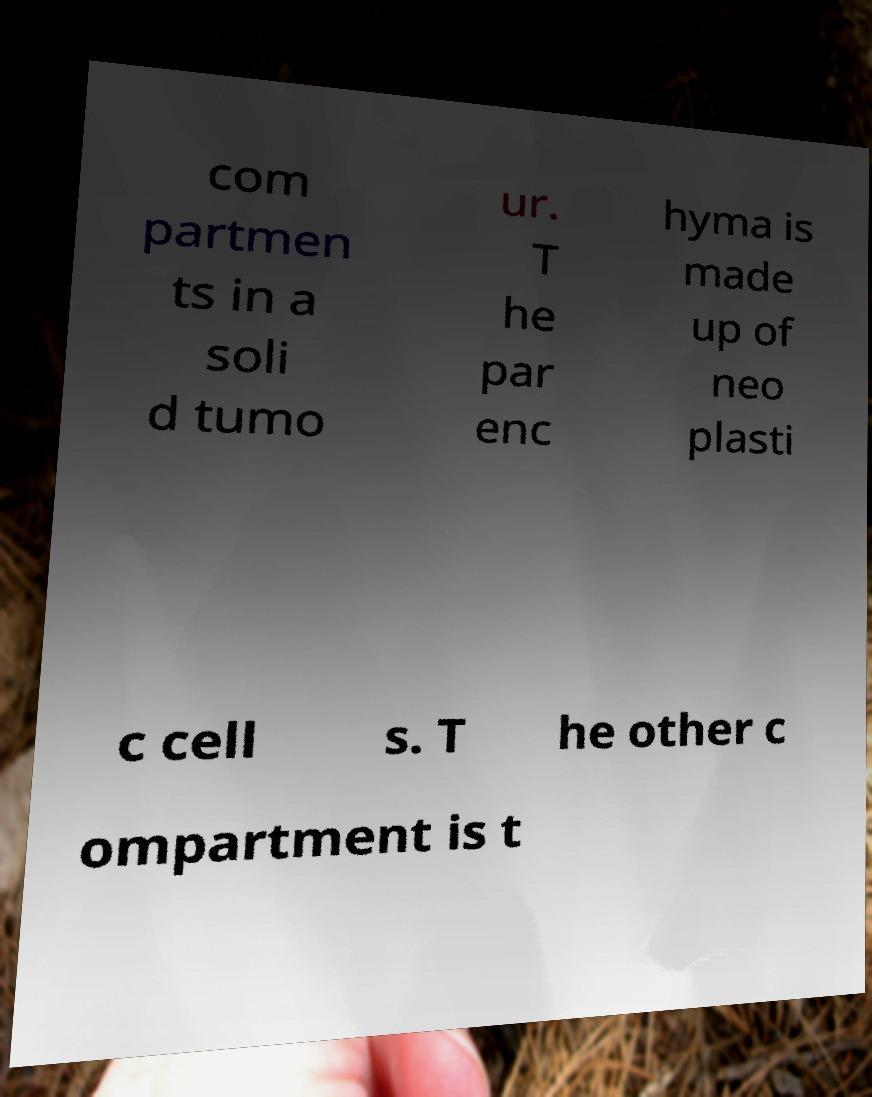Could you extract and type out the text from this image? com partmen ts in a soli d tumo ur. T he par enc hyma is made up of neo plasti c cell s. T he other c ompartment is t 